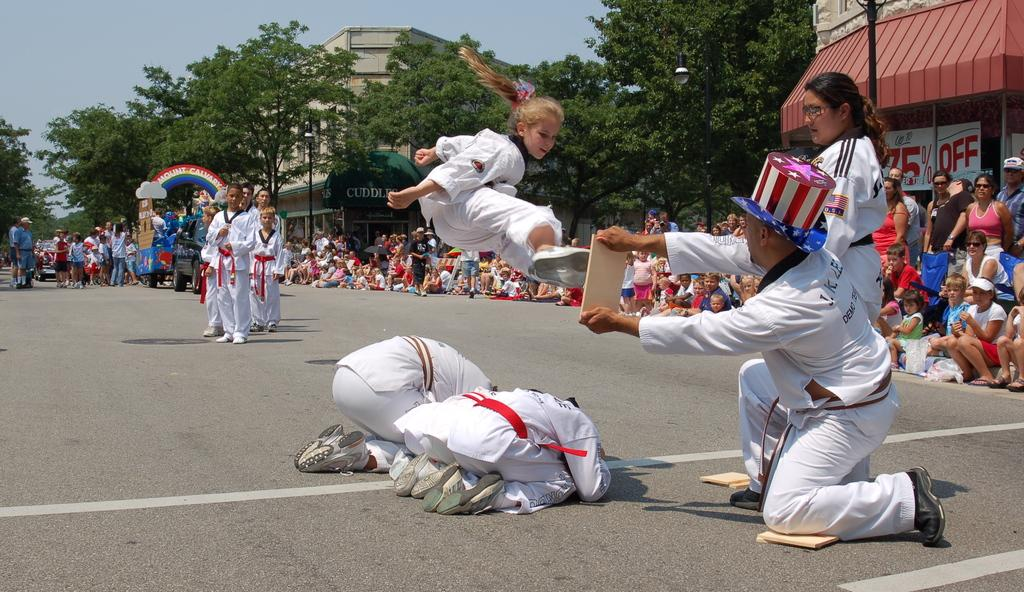How many people are in the image? There is a group of people in the image, but the exact number cannot be determined from the provided facts. What can be seen on the road in the image? There are vehicles on the road in the image. What type of vegetation is present in the image? There are trees in the image. What type of structures are visible in the image? There are buildings in the image. What type of signage is present in the image? There are posters in the image. What other objects can be seen in the image? There are some objects in the image, but their specific nature cannot be determined from the provided facts. What is visible in the background of the image? The sky is visible in the background of the image. What type of cushion is being used for breakfast in the image? There is no cushion or breakfast present in the image. What type of fruit is being used to make a quince pie in the image? There is no quince or pie present in the image. 